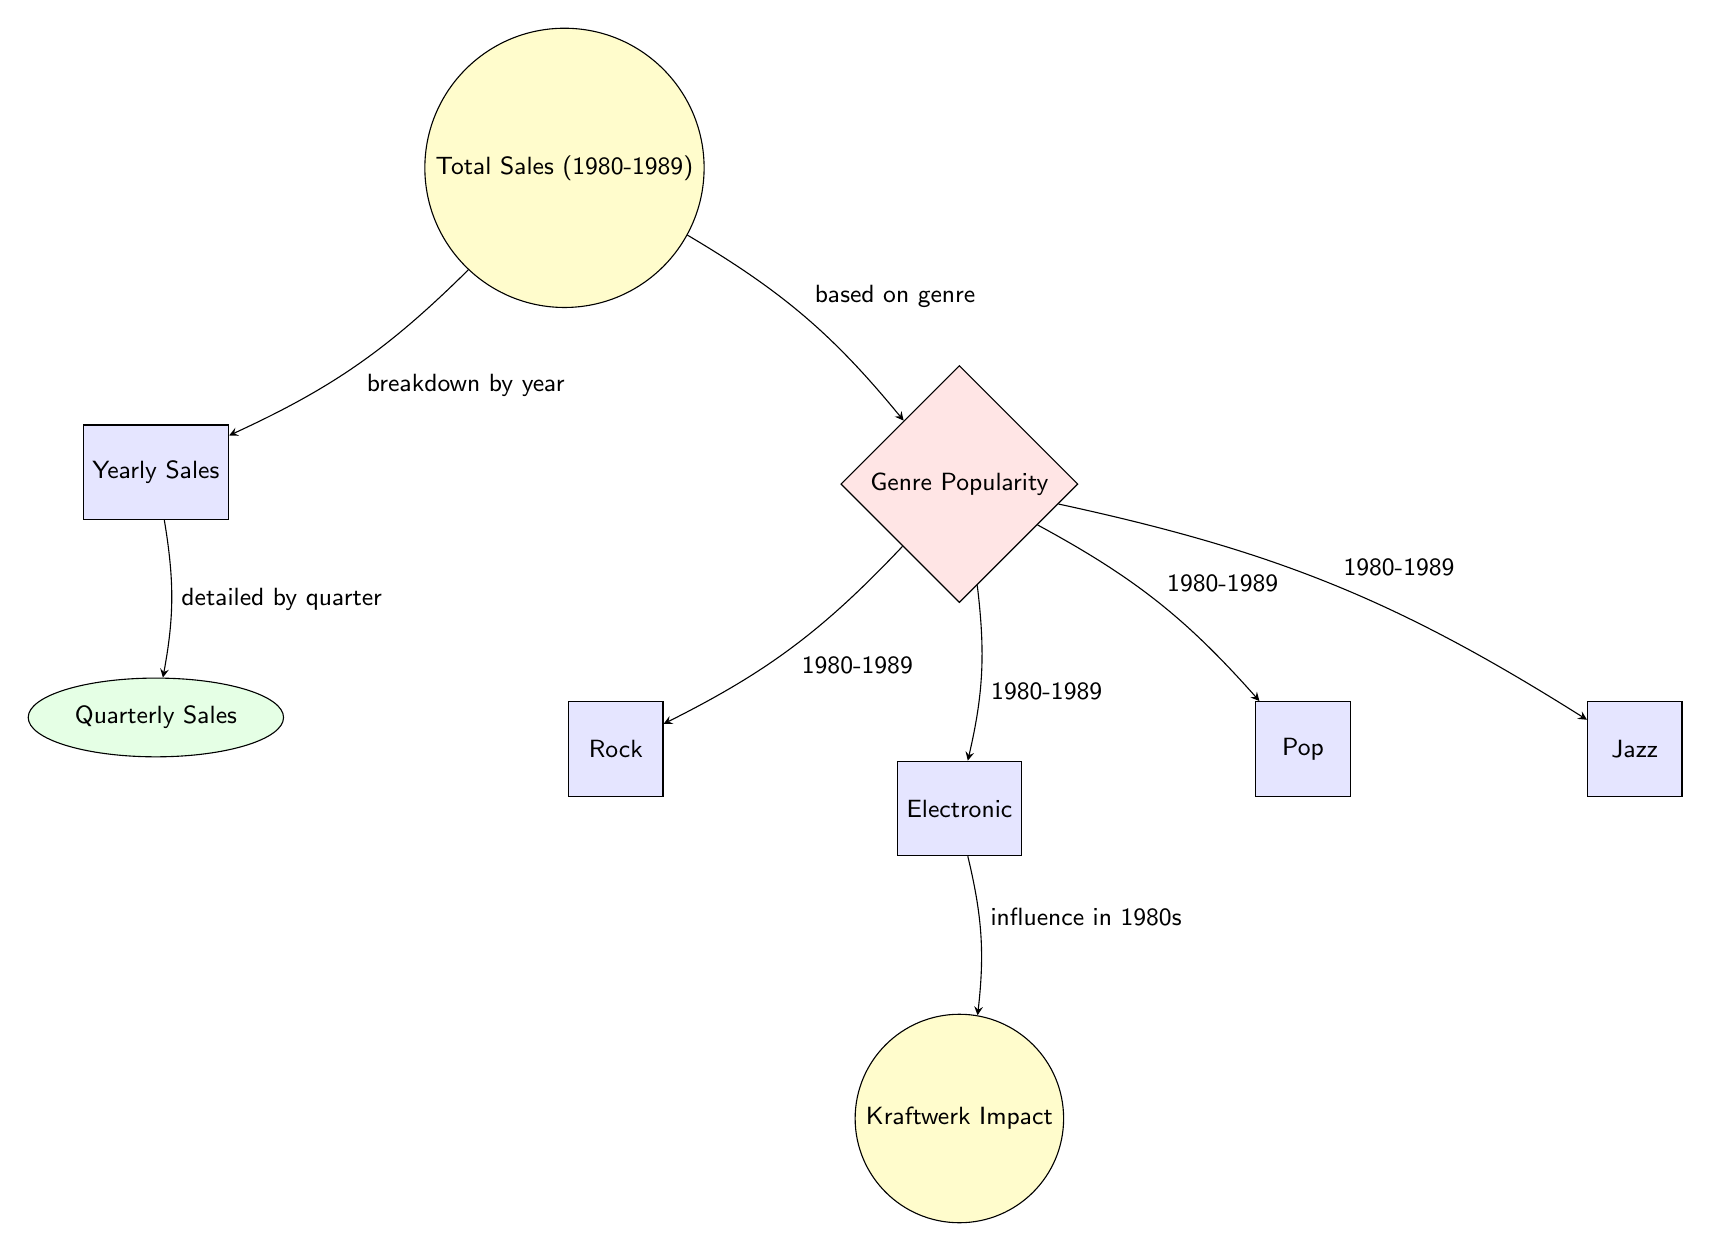What is shown at the top of the diagram? The top node of the diagram represents the overall metric being analyzed, which is the total sales from 1980 to 1989. This node connects to other nodes that break down this information further.
Answer: Total Sales (1980-1989) How many main categories are there under Genre Popularity? The diagram shows four categories under the Genre Popularity node, each represented by its own rectangle node. These categories are Rock, Electronic, Pop, and Jazz.
Answer: 4 Which genre is directly linked to Kraftwerk Impact? The Kraftwerk Impact node is positioned directly below the Electronic genre, indicating that it is influenced by this specific genre within the context of the diagram.
Answer: Electronic What does the arrow from Yearly Sales to Quarterly Sales indicate? The arrow connects these two nodes with a label indicating that it details the yearly sales by quarter, meaning that quarterly sales are a breakdown of the yearly sales figure.
Answer: Detailed by quarter What is the relationship between Total Sales and Genre Popularity? The diagram shows a direct relationship indicated by an arrow, meaning that genre popularity is analyzed based on the total sales figures over the time period specified (1980-1989).
Answer: Based on genre How does the diagram break down Total Sales? The Total Sales node breaks down into Yearly Sales and Genre Popularity, indicating that the total sales data is categorized both by year and by genre over the specified period.
Answer: By year and genre What years does the Vinyl Sales data cover? The time frame specified for the sales data spans ten years, beginning in 1980 and concluding in 1989 as indicated at the top of the diagram.
Answer: 1980-1989 Which genre has an influence highlighted by the node Kraftwerk Impact? The Kraftwerk Impact node is specifically linked to the Electronic genre, showing a significant influence of that genre during the 1980s, particularly from the work of Kraftwerk.
Answer: Electronic What is the shape of the Total Sales node? The Total Sales node is represented as a circle, which visually distinguishes it from other nodes in the diagram and indicates its primary status in the analysis.
Answer: Circle 